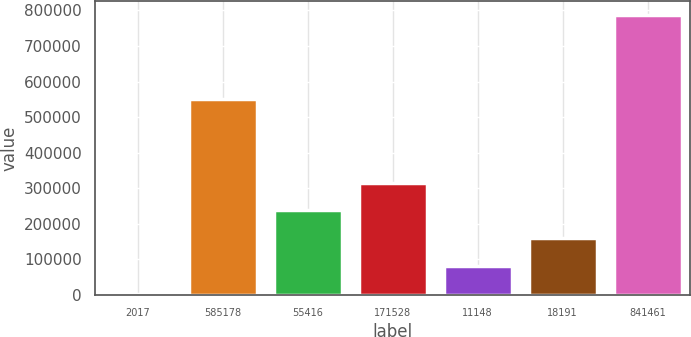<chart> <loc_0><loc_0><loc_500><loc_500><bar_chart><fcel>2017<fcel>585178<fcel>55416<fcel>171528<fcel>11148<fcel>18191<fcel>841461<nl><fcel>2016<fcel>549552<fcel>237386<fcel>315843<fcel>80472.7<fcel>158929<fcel>786583<nl></chart> 